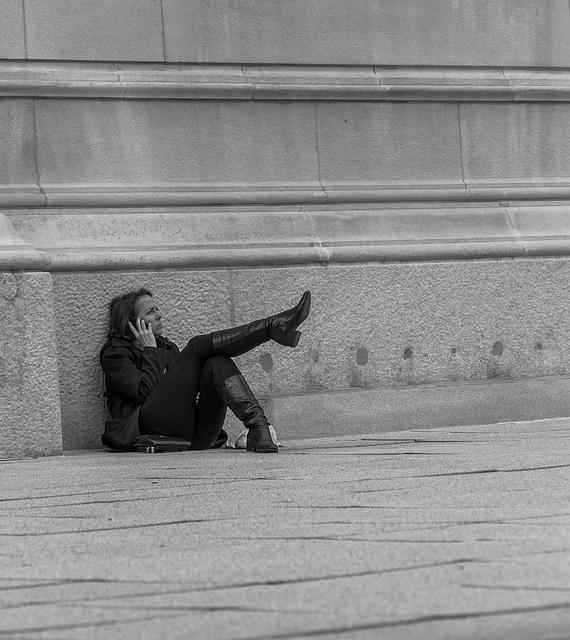What other people are known to sit in locations like this in this position?
Indicate the correct response by choosing from the four available options to answer the question.
Options: Pan handlers, engineers, football players, teachers. Pan handlers. 